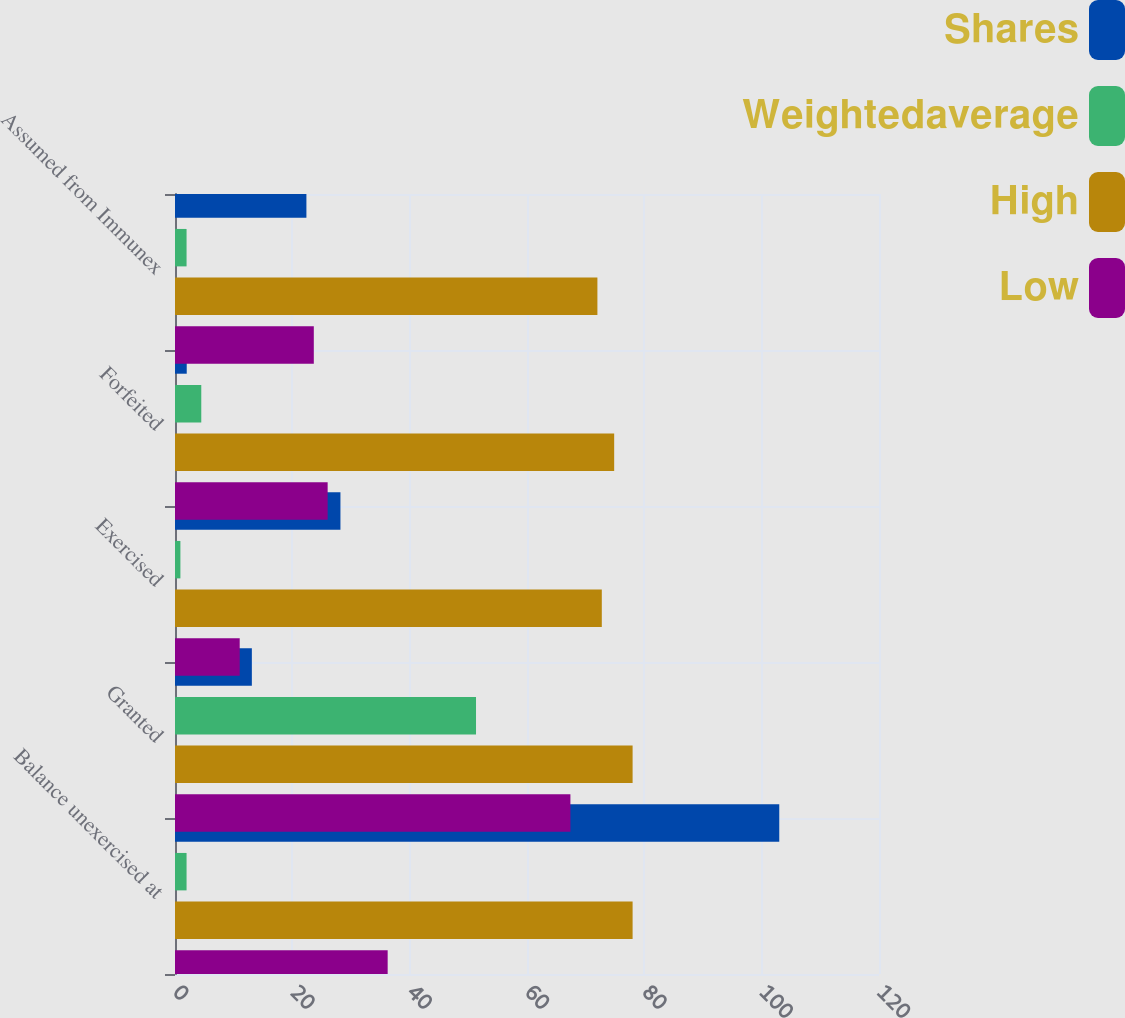Convert chart to OTSL. <chart><loc_0><loc_0><loc_500><loc_500><stacked_bar_chart><ecel><fcel>Balance unexercised at<fcel>Granted<fcel>Exercised<fcel>Forfeited<fcel>Assumed from Immunex<nl><fcel>Shares<fcel>103<fcel>13.1<fcel>28.2<fcel>2<fcel>22.4<nl><fcel>Weightedaverage<fcel>1.97<fcel>51.31<fcel>0.92<fcel>4.48<fcel>1.97<nl><fcel>High<fcel>78<fcel>78<fcel>72.75<fcel>74.86<fcel>72<nl><fcel>Low<fcel>36.25<fcel>67.4<fcel>11.03<fcel>26.02<fcel>23.66<nl></chart> 